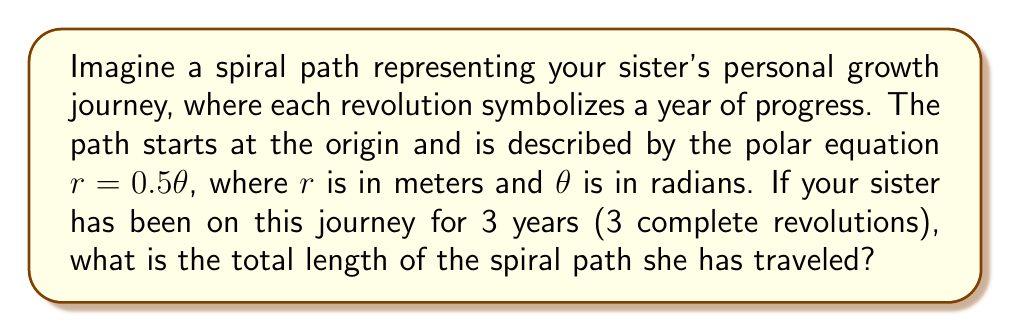Give your solution to this math problem. Let's approach this step-by-step:

1) The formula for the length of a polar curve from $\theta = a$ to $\theta = b$ is:

   $$L = \int_a^b \sqrt{r^2 + \left(\frac{dr}{d\theta}\right)^2} d\theta$$

2) In our case, $r = 0.5\theta$, so $\frac{dr}{d\theta} = 0.5$

3) Substituting these into the formula:

   $$L = \int_0^{6\pi} \sqrt{(0.5\theta)^2 + (0.5)^2} d\theta$$

4) Simplify inside the square root:

   $$L = \int_0^{6\pi} \sqrt{0.25\theta^2 + 0.25} d\theta$$

5) Factor out 0.25:

   $$L = \int_0^{6\pi} 0.5\sqrt{\theta^2 + 1} d\theta$$

6) This integral doesn't have an elementary antiderivative, so we need to use a substitution:

   Let $\theta = \sinh(u)$, then $d\theta = \cosh(u)du$

   When $\theta = 0$, $u = 0$
   When $\theta = 6\pi$, $u = \sinh^{-1}(6\pi)$

7) Substituting:

   $$L = 0.5\int_0^{\sinh^{-1}(6\pi)} \sqrt{\sinh^2(u) + 1} \cosh(u)du$$

8) Simplify using the identity $\sinh^2(u) + 1 = \cosh^2(u)$:

   $$L = 0.5\int_0^{\sinh^{-1}(6\pi)} \cosh^2(u)du$$

9) Use the identity $\cosh^2(u) = \frac{1}{2}(\cosh(2u) + 1)$:

   $$L = 0.25\int_0^{\sinh^{-1}(6\pi)} (\cosh(2u) + 1)du$$

10) Integrate:

    $$L = 0.25\left[\frac{1}{2}\sinh(2u) + u\right]_0^{\sinh^{-1}(6\pi)}$$

11) Evaluate:

    $$L = 0.25\left[\frac{1}{2}\sinh(2\sinh^{-1}(6\pi)) + \sinh^{-1}(6\pi)\right]$$

12) Simplify using $\sinh(2\sinh^{-1}(x)) = 2x\sqrt{1+x^2}$:

    $$L = 0.25\left[6\pi\sqrt{1+(6\pi)^2} + \sinh^{-1}(6\pi)\right]$$

13) Calculate the numerical value (rounded to 2 decimal places):

    $$L \approx 28.56 \text{ meters}$$
Answer: The total length of the spiral path is approximately 28.56 meters. 